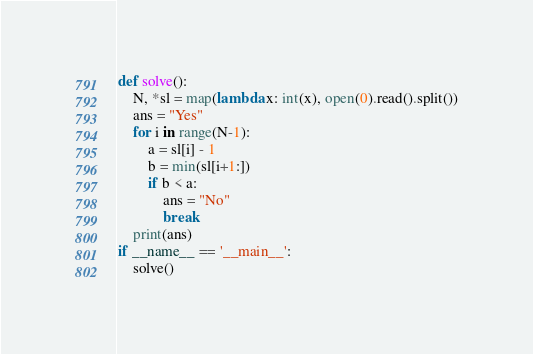<code> <loc_0><loc_0><loc_500><loc_500><_Python_>def solve():
    N, *sl = map(lambda x: int(x), open(0).read().split())
    ans = "Yes"
    for i in range(N-1):
        a = sl[i] - 1
        b = min(sl[i+1:])
        if b < a:
            ans = "No"
            break
    print(ans)  
if __name__ == '__main__':
    solve()
</code> 